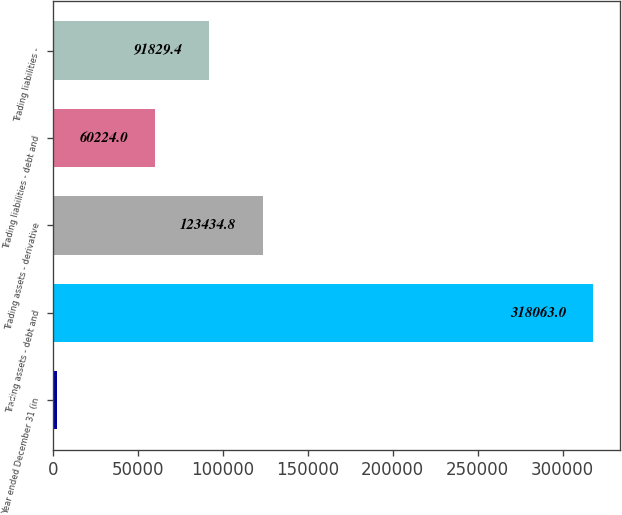Convert chart. <chart><loc_0><loc_0><loc_500><loc_500><bar_chart><fcel>Year ended December 31 (in<fcel>Trading assets - debt and<fcel>Trading assets - derivative<fcel>Trading liabilities - debt and<fcel>Trading liabilities -<nl><fcel>2009<fcel>318063<fcel>123435<fcel>60224<fcel>91829.4<nl></chart> 